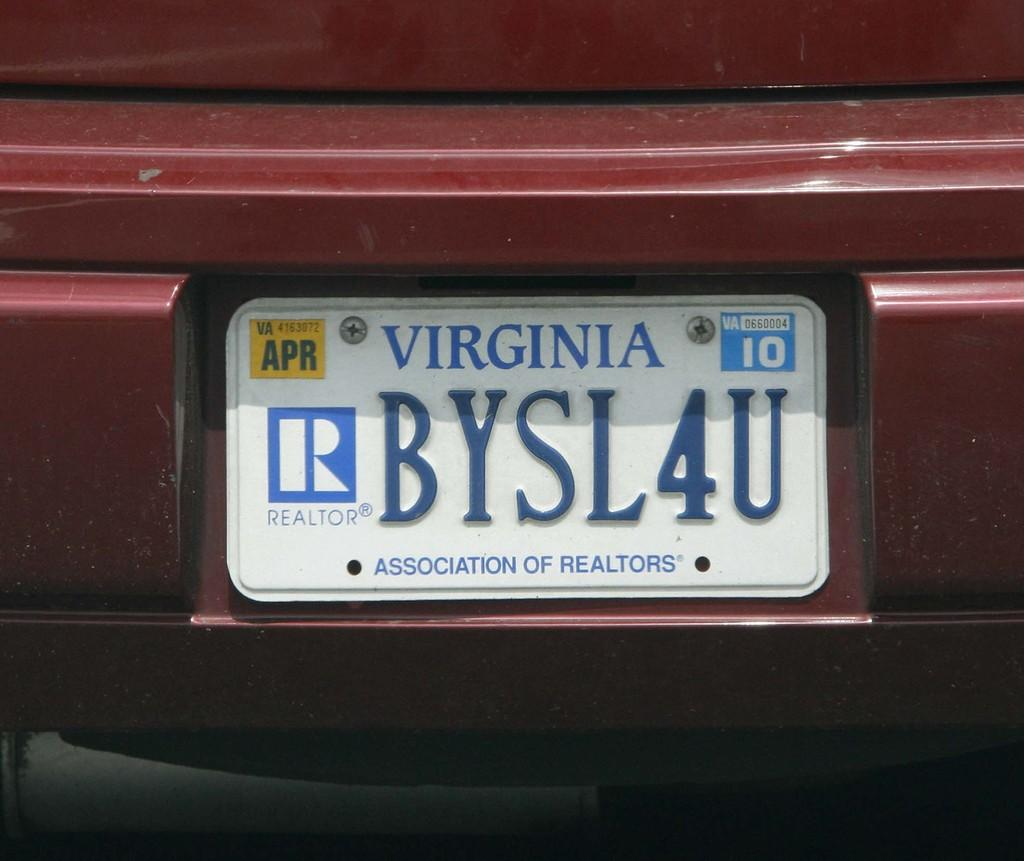Provide a one-sentence caption for the provided image. A Virginia license plate that says "BYSL4U" on it and notes that the driver is a realtor. 